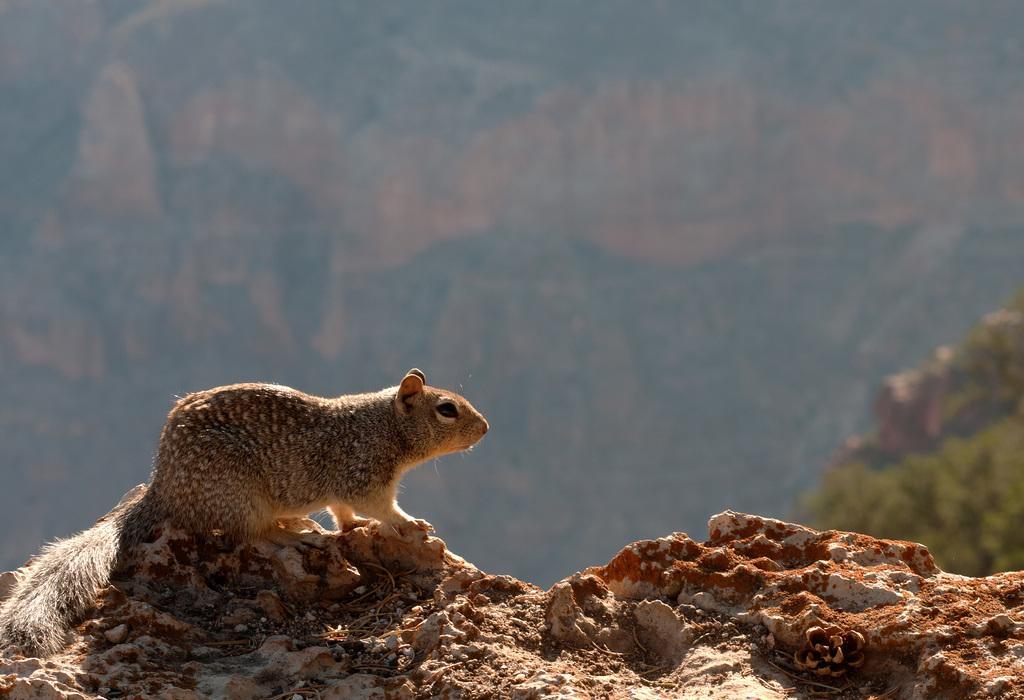In one or two sentences, can you explain what this image depicts? In the image we can see there is a squirrel standing on the rock surface. Behind the image is little blurry. 